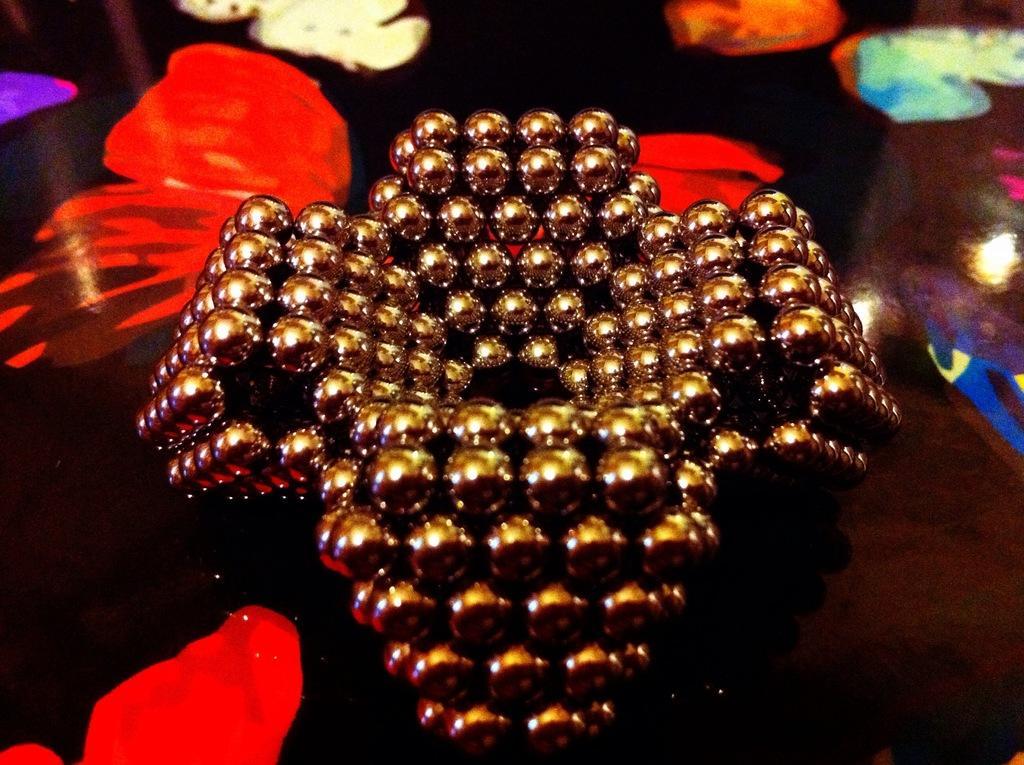Describe this image in one or two sentences. In this picture we can see a decorative item on an object. 